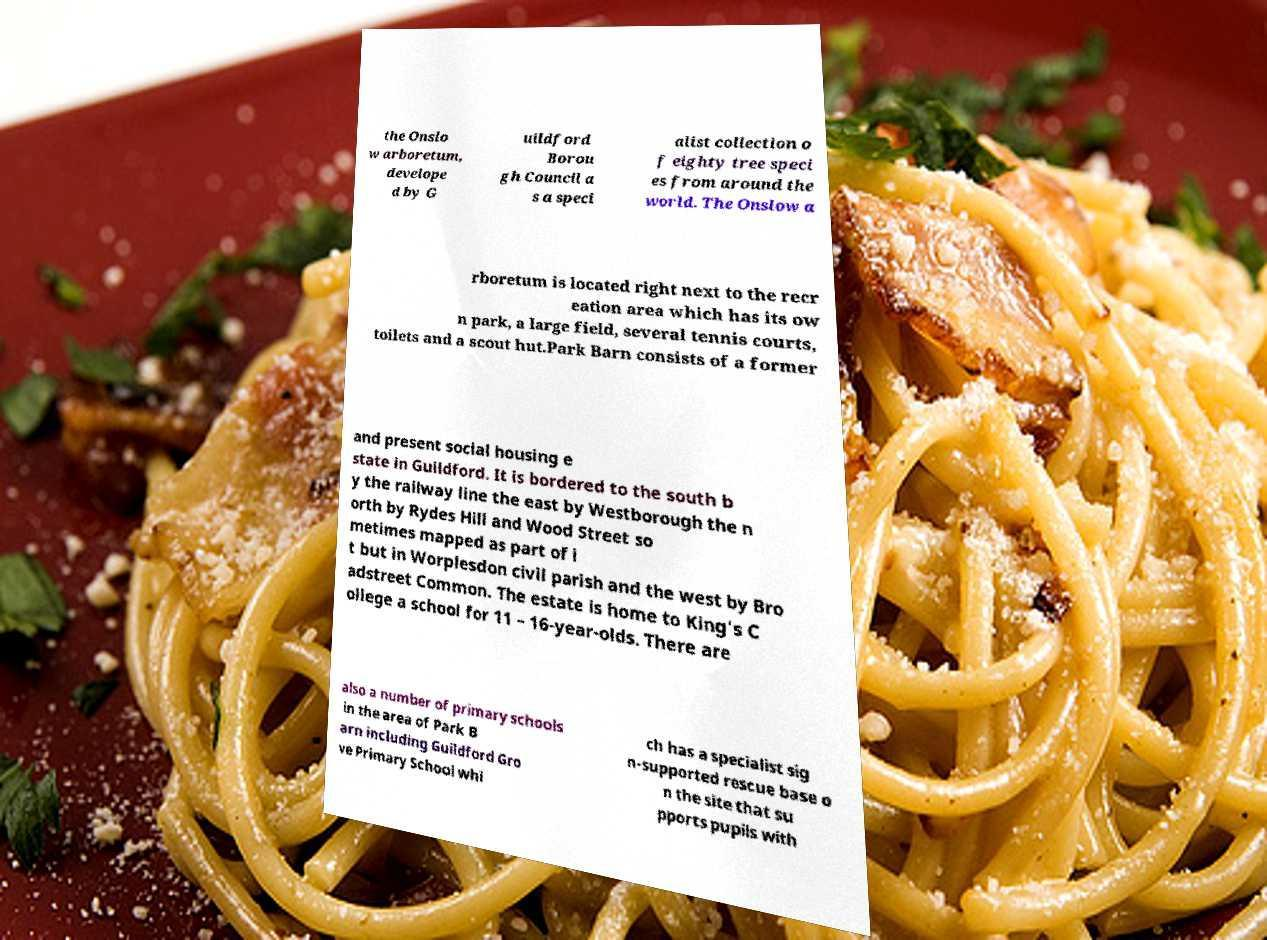For documentation purposes, I need the text within this image transcribed. Could you provide that? the Onslo w arboretum, develope d by G uildford Borou gh Council a s a speci alist collection o f eighty tree speci es from around the world. The Onslow a rboretum is located right next to the recr eation area which has its ow n park, a large field, several tennis courts, toilets and a scout hut.Park Barn consists of a former and present social housing e state in Guildford. It is bordered to the south b y the railway line the east by Westborough the n orth by Rydes Hill and Wood Street so metimes mapped as part of i t but in Worplesdon civil parish and the west by Bro adstreet Common. The estate is home to King's C ollege a school for 11 – 16-year-olds. There are also a number of primary schools in the area of Park B arn including Guildford Gro ve Primary School whi ch has a specialist sig n-supported rescue base o n the site that su pports pupils with 